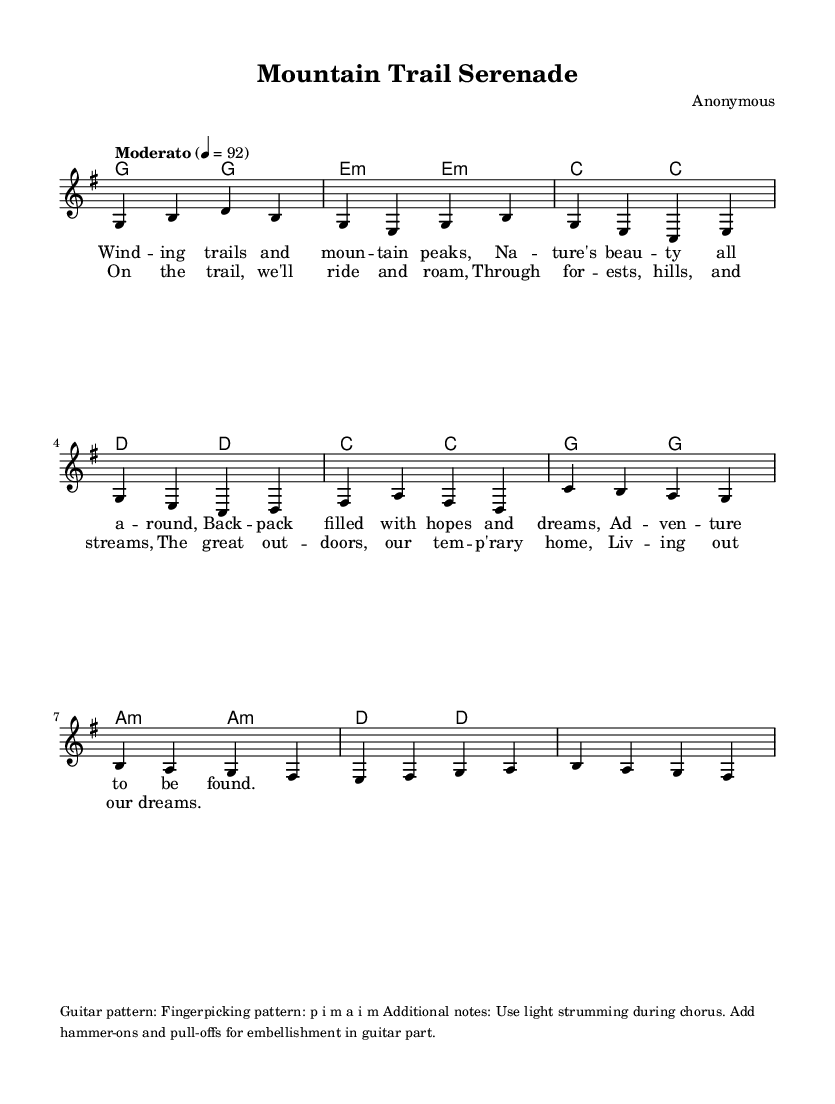What is the key signature of this music? The key signature is indicated at the beginning of the staff, and it shows one sharp, representing G major.
Answer: G major What is the time signature of this music? The time signature is found right after the key signature, indicating that there are four beats in each measure.
Answer: 4/4 What is the tempo marking for this piece? The tempo marking is shown at the beginning of the score, indicating "Moderato," which typically means a moderate speed.
Answer: Moderato How many measures are in the verse section? By counting the melody in the verse section, there are a total of four measures visible.
Answer: 4 Which chords are used in the chorus? The chords specified in the chordmode section for the chorus are C major, G major, A minor, and D major.
Answer: C, G, A minor, D What technique is suggested for playing the guitar during the chorus? The additional notes provide detailing of the guitar performance, stating to "use light strumming" during the chorus to enhance the feel.
Answer: Light strumming What structure is the song based on? Looking at the arrangement, the song has defined sections labeled as "verse" followed by "chorus," which is a common structure in folk music.
Answer: Verse and chorus 